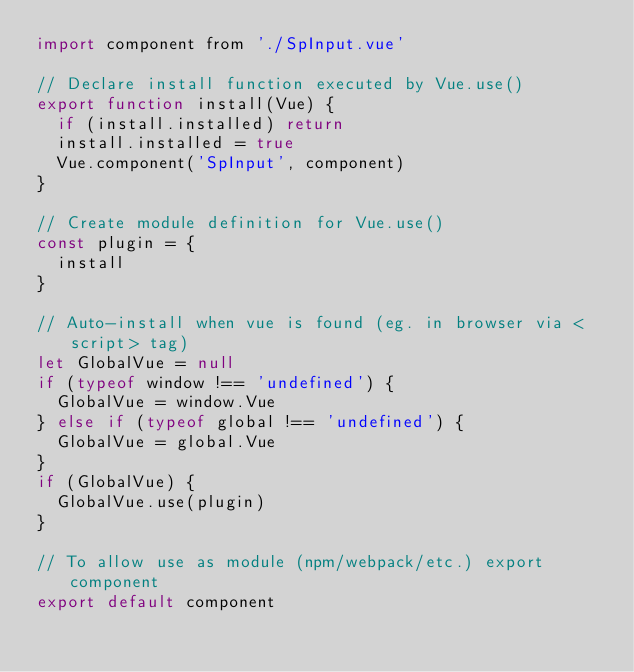<code> <loc_0><loc_0><loc_500><loc_500><_JavaScript_>import component from './SpInput.vue'

// Declare install function executed by Vue.use()
export function install(Vue) {
	if (install.installed) return
	install.installed = true
	Vue.component('SpInput', component)
}

// Create module definition for Vue.use()
const plugin = {
	install
}

// Auto-install when vue is found (eg. in browser via <script> tag)
let GlobalVue = null
if (typeof window !== 'undefined') {
	GlobalVue = window.Vue
} else if (typeof global !== 'undefined') {
	GlobalVue = global.Vue
}
if (GlobalVue) {
	GlobalVue.use(plugin)
}

// To allow use as module (npm/webpack/etc.) export component
export default component
</code> 